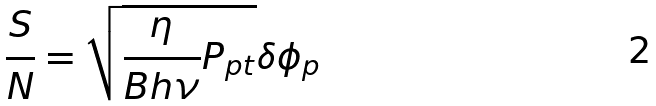Convert formula to latex. <formula><loc_0><loc_0><loc_500><loc_500>\frac { S } { N } = \sqrt { \frac { \eta } { B h \nu } P _ { p t } } \delta \phi _ { p }</formula> 